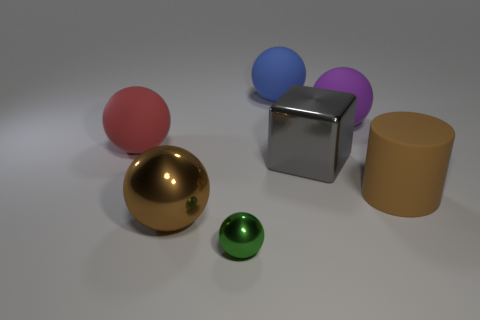Subtract all blue spheres. How many spheres are left? 4 Subtract all brown balls. How many balls are left? 4 Subtract all cyan balls. Subtract all green cylinders. How many balls are left? 5 Add 2 green balls. How many objects exist? 9 Subtract all balls. How many objects are left? 2 Subtract 1 blue spheres. How many objects are left? 6 Subtract all red objects. Subtract all large red matte objects. How many objects are left? 5 Add 2 big blue matte objects. How many big blue matte objects are left? 3 Add 5 large blue balls. How many large blue balls exist? 6 